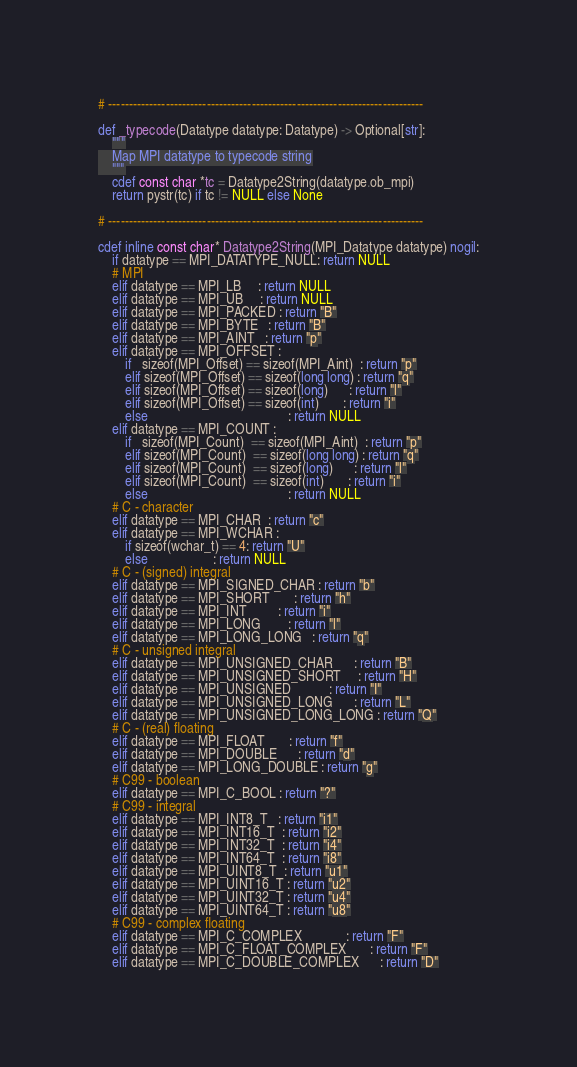Convert code to text. <code><loc_0><loc_0><loc_500><loc_500><_Cython_># -----------------------------------------------------------------------------

def _typecode(Datatype datatype: Datatype) -> Optional[str]:
    """
    Map MPI datatype to typecode string
    """
    cdef const char *tc = Datatype2String(datatype.ob_mpi)
    return pystr(tc) if tc != NULL else None

# -----------------------------------------------------------------------------

cdef inline const char* Datatype2String(MPI_Datatype datatype) nogil:
    if datatype == MPI_DATATYPE_NULL: return NULL
    # MPI
    elif datatype == MPI_LB     : return NULL
    elif datatype == MPI_UB     : return NULL
    elif datatype == MPI_PACKED : return "B"
    elif datatype == MPI_BYTE   : return "B"
    elif datatype == MPI_AINT   : return "p"
    elif datatype == MPI_OFFSET :
        if   sizeof(MPI_Offset) == sizeof(MPI_Aint)  : return "p"
        elif sizeof(MPI_Offset) == sizeof(long long) : return "q"
        elif sizeof(MPI_Offset) == sizeof(long)      : return "l"
        elif sizeof(MPI_Offset) == sizeof(int)       : return "i"
        else                                         : return NULL
    elif datatype == MPI_COUNT :
        if   sizeof(MPI_Count)  == sizeof(MPI_Aint)  : return "p"
        elif sizeof(MPI_Count)  == sizeof(long long) : return "q"
        elif sizeof(MPI_Count)  == sizeof(long)      : return "l"
        elif sizeof(MPI_Count)  == sizeof(int)       : return "i"
        else                                         : return NULL
    # C - character
    elif datatype == MPI_CHAR  : return "c"
    elif datatype == MPI_WCHAR :
        if sizeof(wchar_t) == 4: return "U"
        else                   : return NULL
    # C - (signed) integral
    elif datatype == MPI_SIGNED_CHAR : return "b"
    elif datatype == MPI_SHORT       : return "h"
    elif datatype == MPI_INT         : return "i"
    elif datatype == MPI_LONG        : return "l"
    elif datatype == MPI_LONG_LONG   : return "q"
    # C - unsigned integral
    elif datatype == MPI_UNSIGNED_CHAR      : return "B"
    elif datatype == MPI_UNSIGNED_SHORT     : return "H"
    elif datatype == MPI_UNSIGNED           : return "I"
    elif datatype == MPI_UNSIGNED_LONG      : return "L"
    elif datatype == MPI_UNSIGNED_LONG_LONG : return "Q"
    # C - (real) floating
    elif datatype == MPI_FLOAT       : return "f"
    elif datatype == MPI_DOUBLE      : return "d"
    elif datatype == MPI_LONG_DOUBLE : return "g"
    # C99 - boolean
    elif datatype == MPI_C_BOOL : return "?"
    # C99 - integral
    elif datatype == MPI_INT8_T   : return "i1"
    elif datatype == MPI_INT16_T  : return "i2"
    elif datatype == MPI_INT32_T  : return "i4"
    elif datatype == MPI_INT64_T  : return "i8"
    elif datatype == MPI_UINT8_T  : return "u1"
    elif datatype == MPI_UINT16_T : return "u2"
    elif datatype == MPI_UINT32_T : return "u4"
    elif datatype == MPI_UINT64_T : return "u8"
    # C99 - complex floating
    elif datatype == MPI_C_COMPLEX             : return "F"
    elif datatype == MPI_C_FLOAT_COMPLEX       : return "F"
    elif datatype == MPI_C_DOUBLE_COMPLEX      : return "D"</code> 